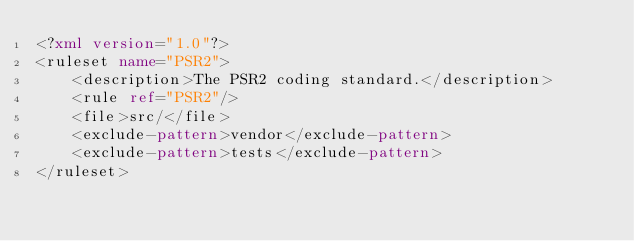Convert code to text. <code><loc_0><loc_0><loc_500><loc_500><_XML_><?xml version="1.0"?>
<ruleset name="PSR2">
    <description>The PSR2 coding standard.</description>
    <rule ref="PSR2"/>
    <file>src/</file>
    <exclude-pattern>vendor</exclude-pattern>
    <exclude-pattern>tests</exclude-pattern>
</ruleset>
</code> 